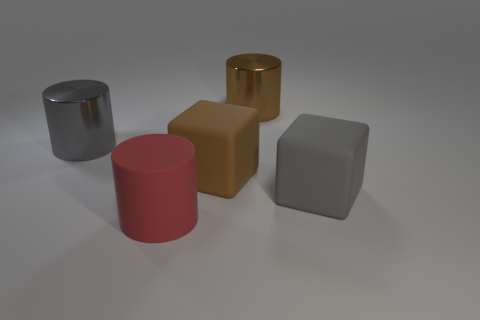How could these objects be used in a real-world setting? These objects can serve various practical and decorative purposes. The metallic cylinder might be a container or a modernist vase. The matte brown block could be a paperweight or part of a child's building blocks set. The gold cube could be a decorative piece or a luxurious doorstop. The red cylinder might be a simplistic modern stool or another decorative element, while the gray cube could be used as an eraser for chalk or whiteboards, a stress-relief squishy toy, or a functional part of a larger machine, given its rubber-like texture. 